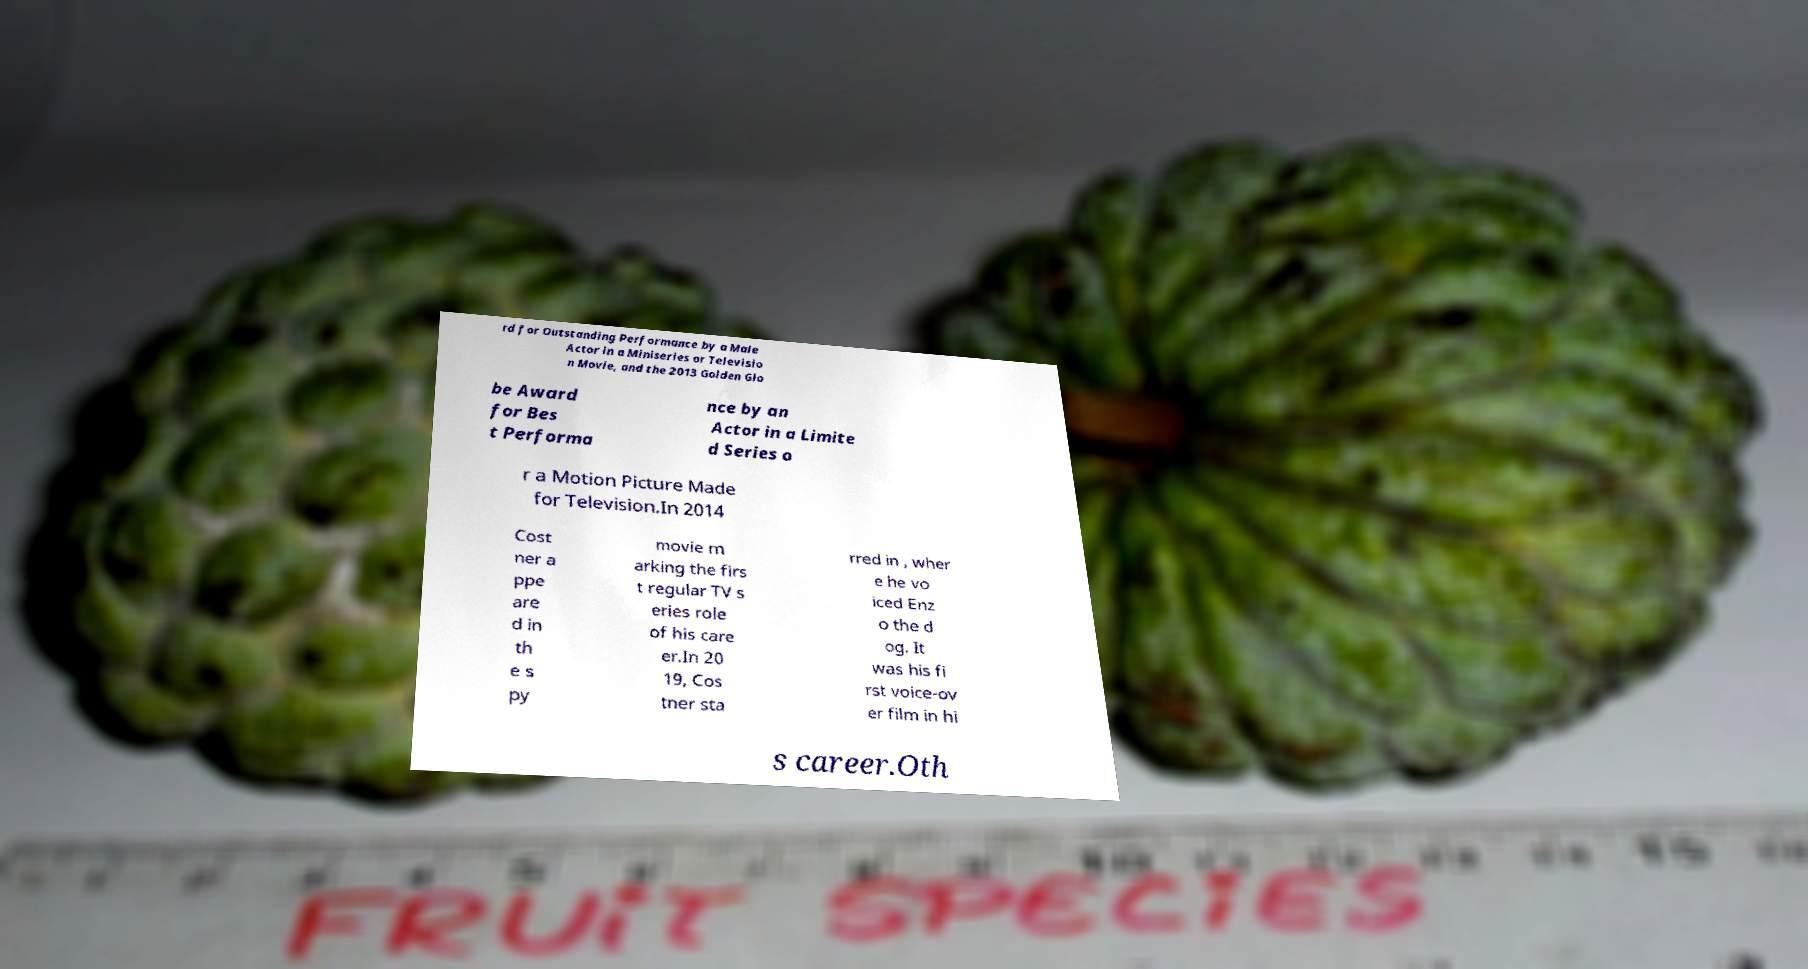Can you accurately transcribe the text from the provided image for me? rd for Outstanding Performance by a Male Actor in a Miniseries or Televisio n Movie, and the 2013 Golden Glo be Award for Bes t Performa nce by an Actor in a Limite d Series o r a Motion Picture Made for Television.In 2014 Cost ner a ppe are d in th e s py movie m arking the firs t regular TV s eries role of his care er.In 20 19, Cos tner sta rred in , wher e he vo iced Enz o the d og. It was his fi rst voice-ov er film in hi s career.Oth 